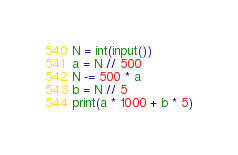Convert code to text. <code><loc_0><loc_0><loc_500><loc_500><_Python_>N = int(input())
a = N // 500
N -= 500 * a
b = N // 5
print(a * 1000 + b * 5)
</code> 